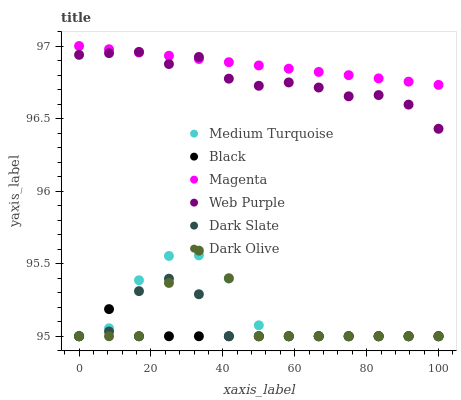Does Black have the minimum area under the curve?
Answer yes or no. Yes. Does Magenta have the maximum area under the curve?
Answer yes or no. Yes. Does Dark Slate have the minimum area under the curve?
Answer yes or no. No. Does Dark Slate have the maximum area under the curve?
Answer yes or no. No. Is Magenta the smoothest?
Answer yes or no. Yes. Is Dark Olive the roughest?
Answer yes or no. Yes. Is Dark Slate the smoothest?
Answer yes or no. No. Is Dark Slate the roughest?
Answer yes or no. No. Does Dark Olive have the lowest value?
Answer yes or no. Yes. Does Web Purple have the lowest value?
Answer yes or no. No. Does Magenta have the highest value?
Answer yes or no. Yes. Does Dark Slate have the highest value?
Answer yes or no. No. Is Medium Turquoise less than Magenta?
Answer yes or no. Yes. Is Magenta greater than Black?
Answer yes or no. Yes. Does Medium Turquoise intersect Dark Olive?
Answer yes or no. Yes. Is Medium Turquoise less than Dark Olive?
Answer yes or no. No. Is Medium Turquoise greater than Dark Olive?
Answer yes or no. No. Does Medium Turquoise intersect Magenta?
Answer yes or no. No. 